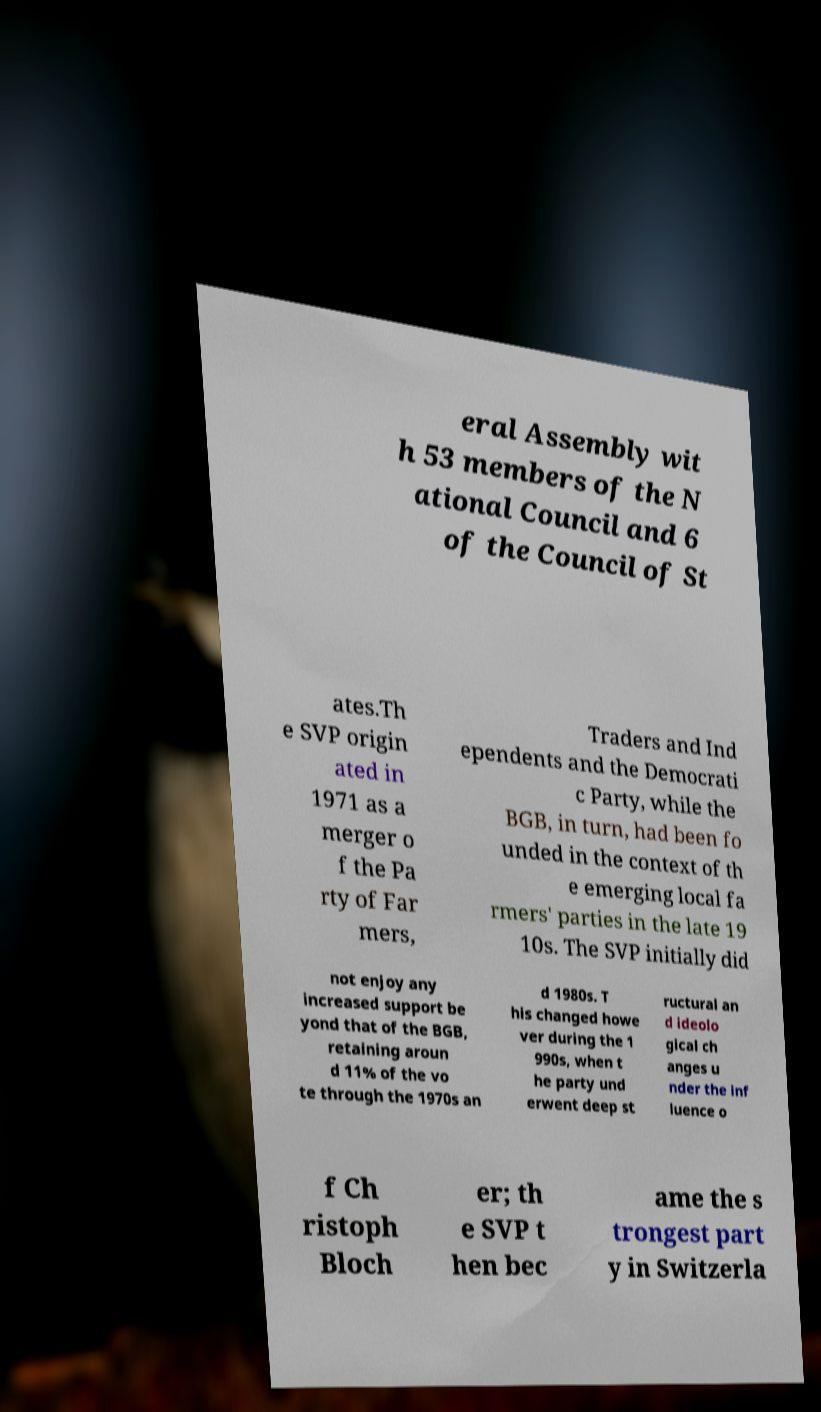Can you read and provide the text displayed in the image?This photo seems to have some interesting text. Can you extract and type it out for me? eral Assembly wit h 53 members of the N ational Council and 6 of the Council of St ates.Th e SVP origin ated in 1971 as a merger o f the Pa rty of Far mers, Traders and Ind ependents and the Democrati c Party, while the BGB, in turn, had been fo unded in the context of th e emerging local fa rmers' parties in the late 19 10s. The SVP initially did not enjoy any increased support be yond that of the BGB, retaining aroun d 11% of the vo te through the 1970s an d 1980s. T his changed howe ver during the 1 990s, when t he party und erwent deep st ructural an d ideolo gical ch anges u nder the inf luence o f Ch ristoph Bloch er; th e SVP t hen bec ame the s trongest part y in Switzerla 